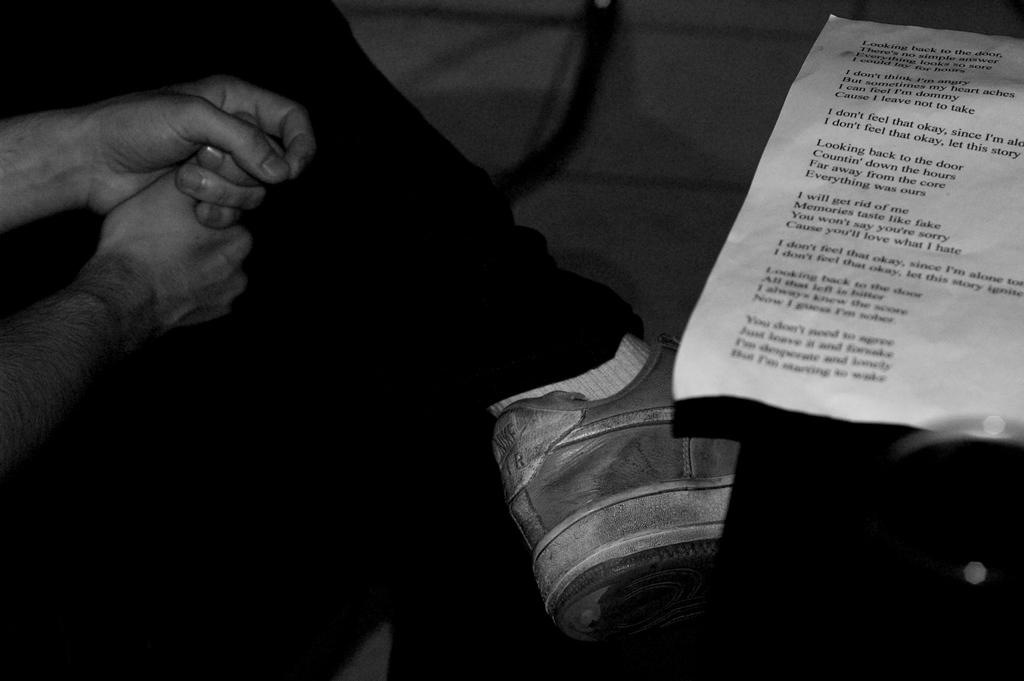Where is the person located in the image? There is a person sitting in the left corner of the image. What is present in the right corner of the image? There is a paper in the right corner of the image. What can be observed on the paper? The paper has something written on it. What type of bait is the person using in the image? There is no bait present in the image; it features a person sitting and a paper with writing. Can you see the person's stomach in the image? The image does not show the person's stomach; it only shows the person sitting in the left corner. 